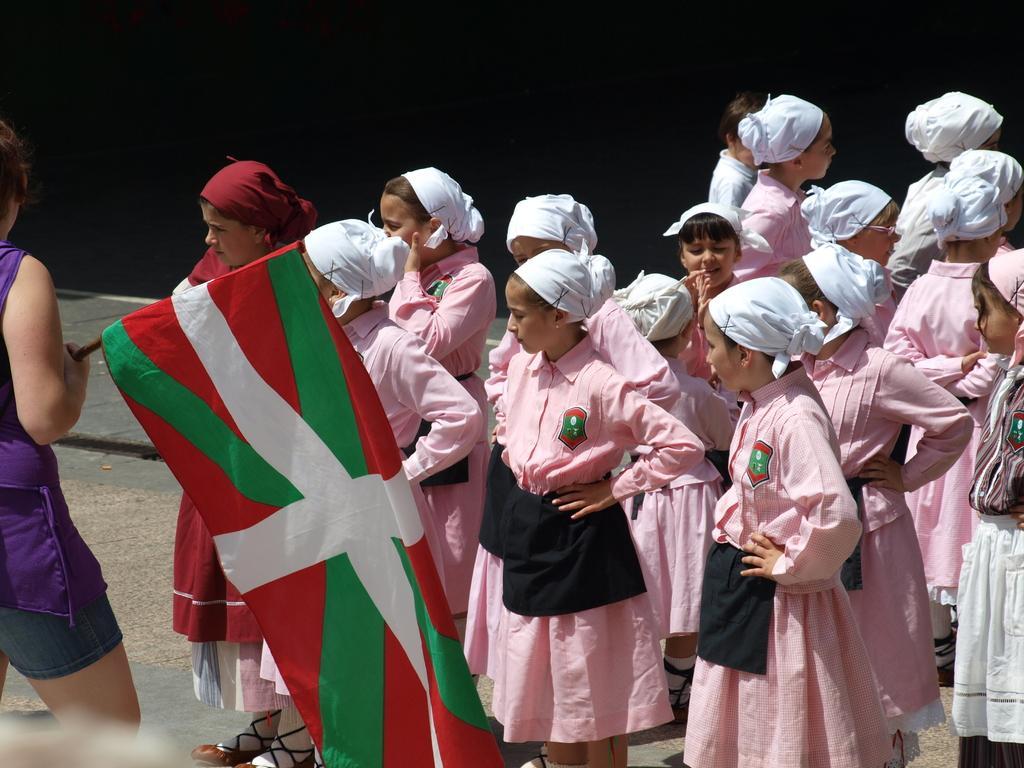How would you summarize this image in a sentence or two? In the picture,there are group of girls standing in an area they are wearing pink uniform and a white cloth tied to their heads,in the front there is a girl holding a flag in her hand and she is wearing a purple dress and in the background there is a black cloth. 